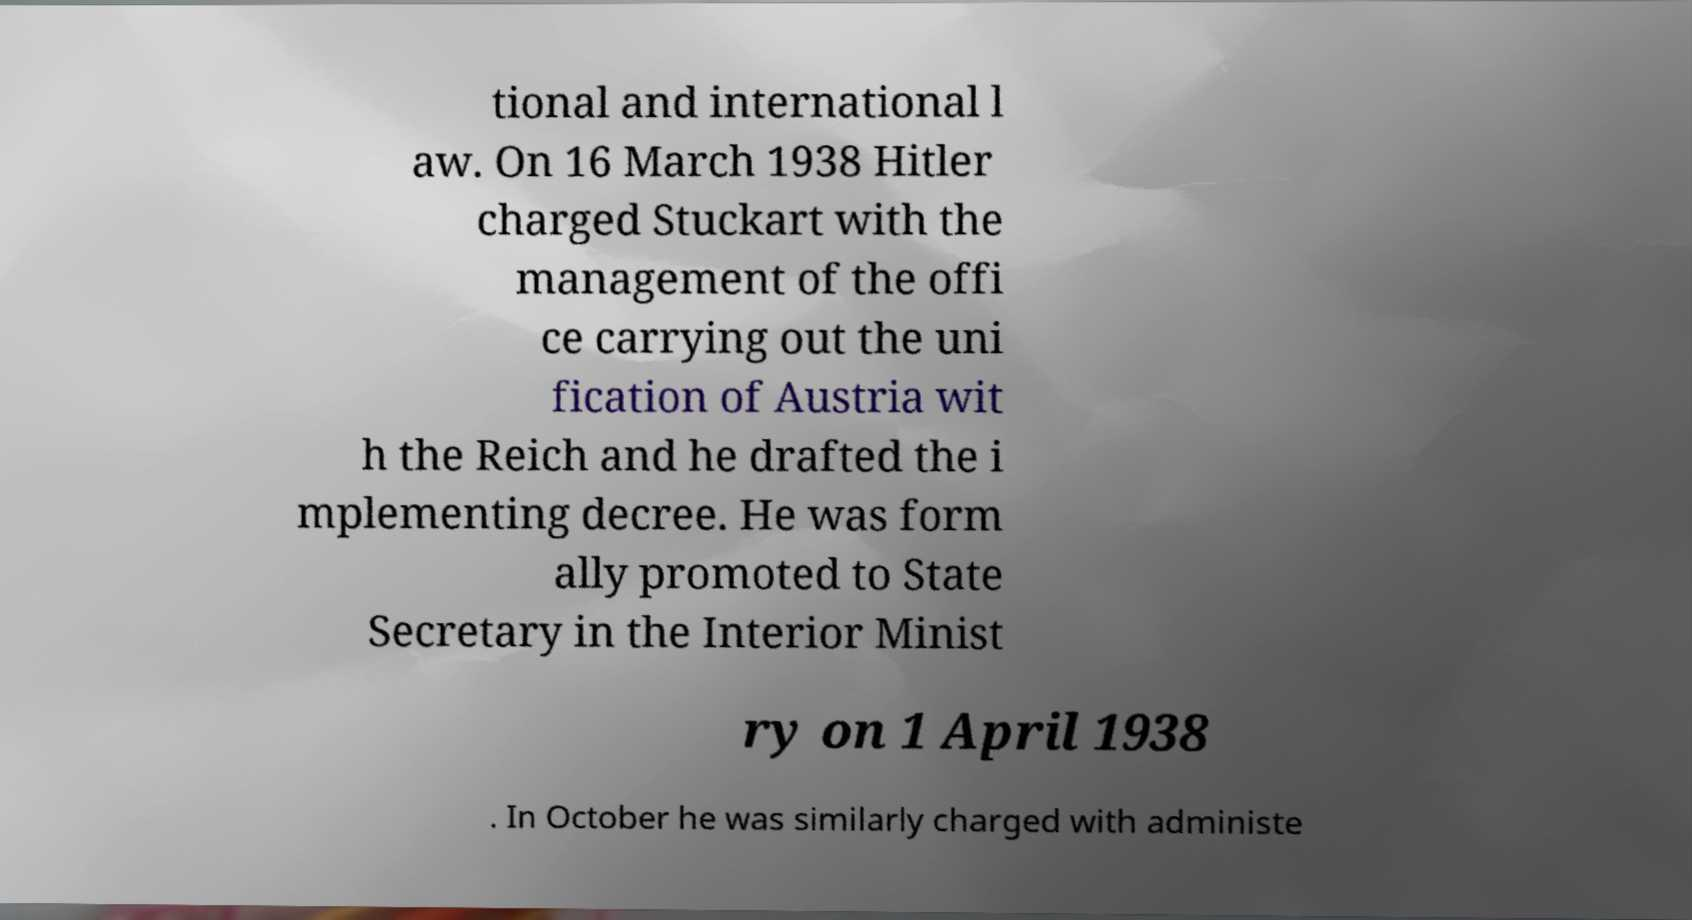For documentation purposes, I need the text within this image transcribed. Could you provide that? tional and international l aw. On 16 March 1938 Hitler charged Stuckart with the management of the offi ce carrying out the uni fication of Austria wit h the Reich and he drafted the i mplementing decree. He was form ally promoted to State Secretary in the Interior Minist ry on 1 April 1938 . In October he was similarly charged with administe 